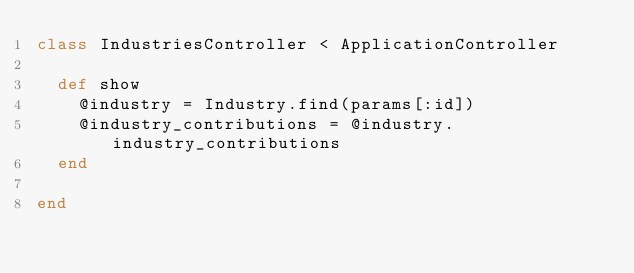<code> <loc_0><loc_0><loc_500><loc_500><_Ruby_>class IndustriesController < ApplicationController

  def show
    @industry = Industry.find(params[:id])
    @industry_contributions = @industry.industry_contributions
  end

end
</code> 